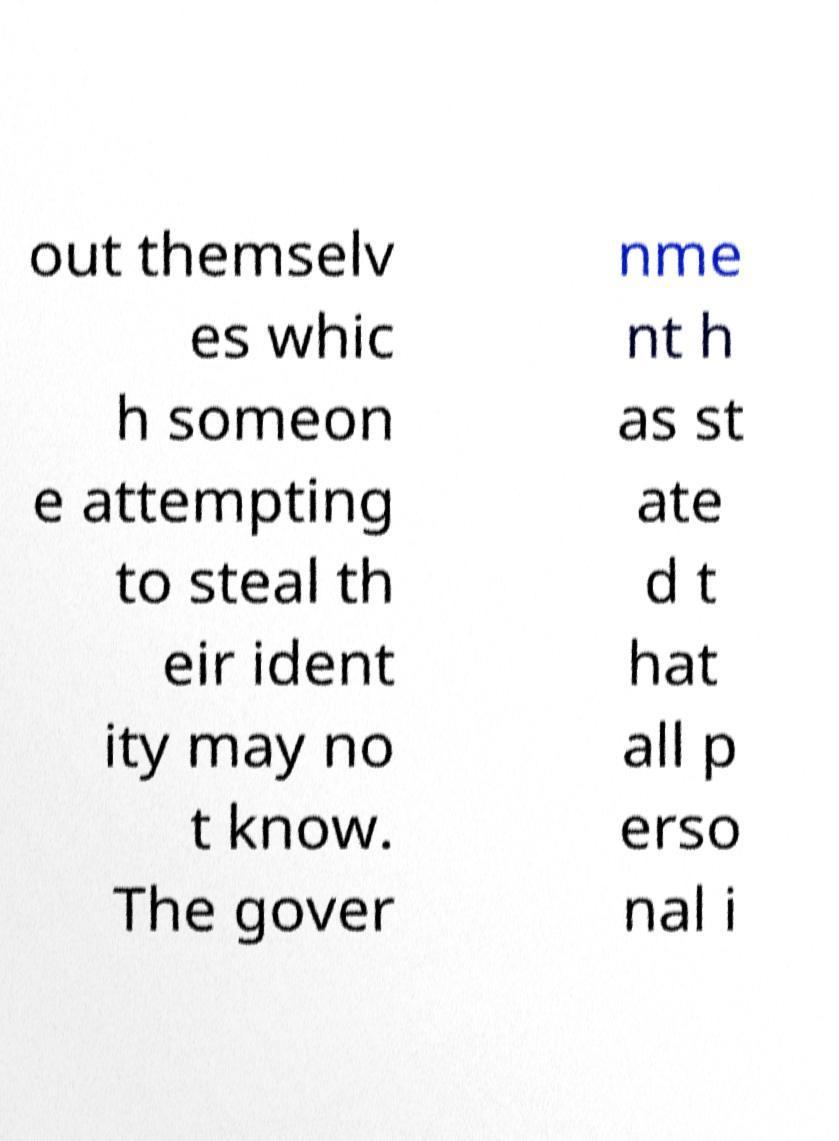For documentation purposes, I need the text within this image transcribed. Could you provide that? Certainly! The text in the image reads: 'out themselves which someone attempting to steal their identity may not know. The government has stated that all personal i...'. Please note that the text is partially visible and may be missing context for complete understanding. 